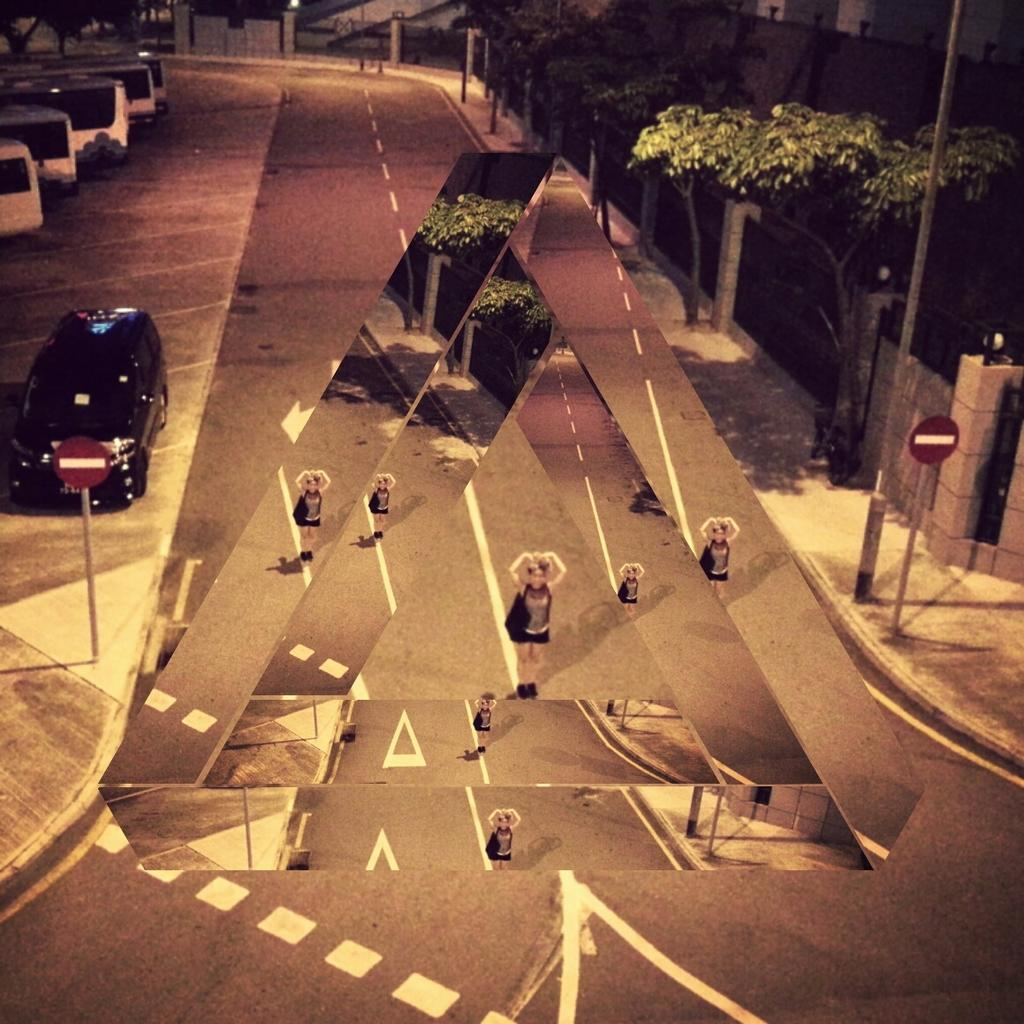What is the girl doing in the image? The girl is standing on a road in the image. What else can be seen near the girl? There are cars beside the road in the image. What type of vegetation is on the right side of the image? There are trees on the right side of the image. What type of square structure can be seen in the image? There is no square structure present in the image. Is there a maid visible in the image? There is no maid present in the image. 